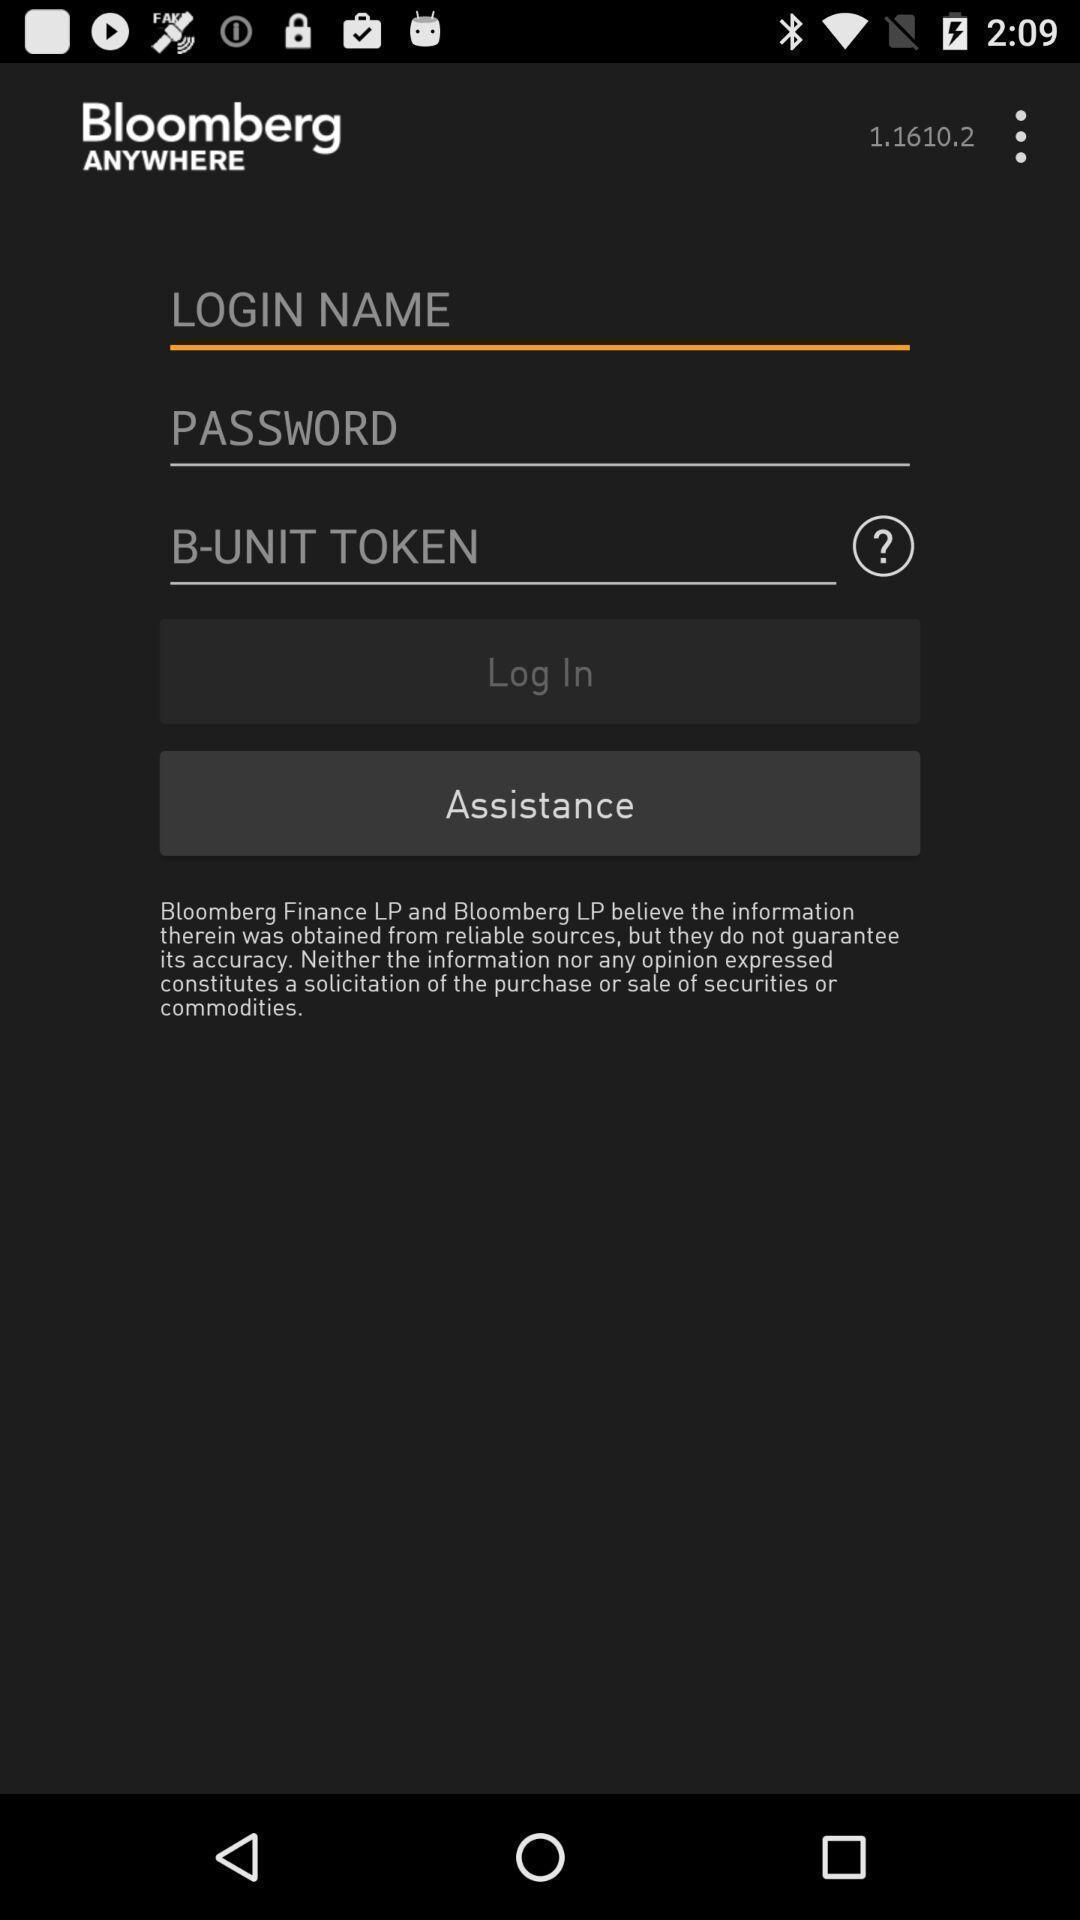What can you discern from this picture? Page showing login page. 